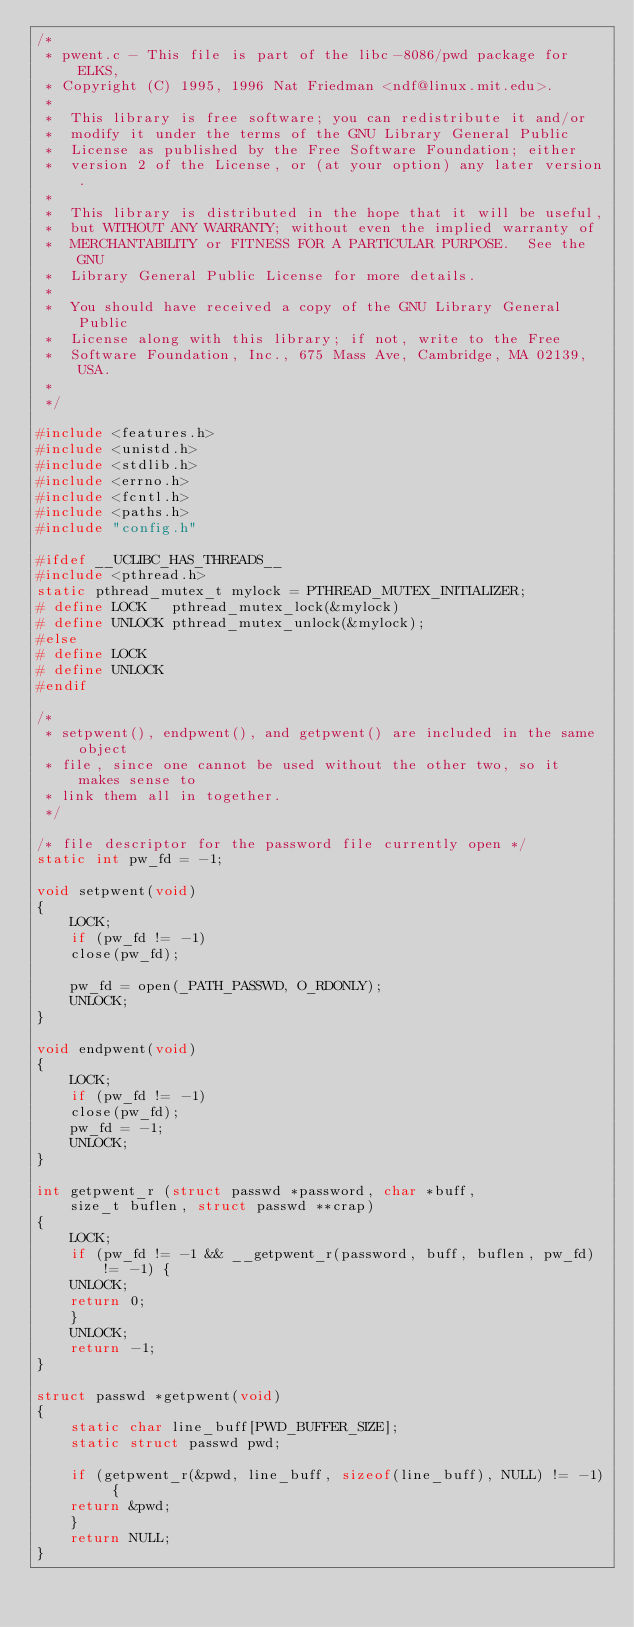Convert code to text. <code><loc_0><loc_0><loc_500><loc_500><_C_>/*
 * pwent.c - This file is part of the libc-8086/pwd package for ELKS,
 * Copyright (C) 1995, 1996 Nat Friedman <ndf@linux.mit.edu>.
 * 
 *  This library is free software; you can redistribute it and/or
 *  modify it under the terms of the GNU Library General Public
 *  License as published by the Free Software Foundation; either
 *  version 2 of the License, or (at your option) any later version.
 *
 *  This library is distributed in the hope that it will be useful,
 *  but WITHOUT ANY WARRANTY; without even the implied warranty of
 *  MERCHANTABILITY or FITNESS FOR A PARTICULAR PURPOSE.  See the GNU
 *  Library General Public License for more details.
 *
 *  You should have received a copy of the GNU Library General Public
 *  License along with this library; if not, write to the Free
 *  Software Foundation, Inc., 675 Mass Ave, Cambridge, MA 02139, USA.
 *
 */

#include <features.h>
#include <unistd.h>
#include <stdlib.h>
#include <errno.h>
#include <fcntl.h>
#include <paths.h>
#include "config.h"

#ifdef __UCLIBC_HAS_THREADS__
#include <pthread.h>
static pthread_mutex_t mylock = PTHREAD_MUTEX_INITIALIZER;
# define LOCK   pthread_mutex_lock(&mylock)
# define UNLOCK pthread_mutex_unlock(&mylock);
#else       
# define LOCK
# define UNLOCK
#endif      

/*
 * setpwent(), endpwent(), and getpwent() are included in the same object
 * file, since one cannot be used without the other two, so it makes sense to
 * link them all in together.
 */

/* file descriptor for the password file currently open */
static int pw_fd = -1;

void setpwent(void)
{
    LOCK;
    if (pw_fd != -1)
	close(pw_fd);

    pw_fd = open(_PATH_PASSWD, O_RDONLY);
    UNLOCK;
}

void endpwent(void)
{
    LOCK;
    if (pw_fd != -1)
	close(pw_fd);
    pw_fd = -1;
    UNLOCK;
}

int getpwent_r (struct passwd *password, char *buff, 
	size_t buflen, struct passwd **crap)
{
    LOCK;
    if (pw_fd != -1 && __getpwent_r(password, buff, buflen, pw_fd) != -1) {
	UNLOCK;
	return 0;
    }
    UNLOCK;
    return -1;
}

struct passwd *getpwent(void)
{
    static char line_buff[PWD_BUFFER_SIZE];
    static struct passwd pwd;

    if (getpwent_r(&pwd, line_buff, sizeof(line_buff), NULL) != -1) {
	return &pwd;
    }
    return NULL;
}

</code> 